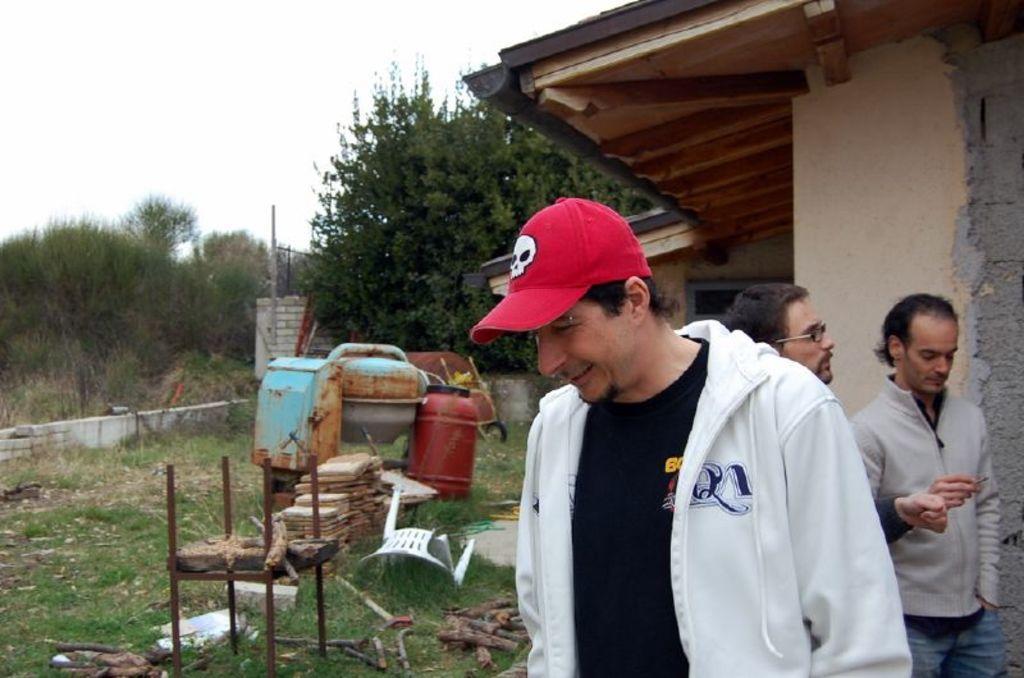How would you summarize this image in a sentence or two? In this image we can see many objects on the ground. There are few trees and plants in the image. There are few people at the right side of the image. A person is wearing a cap. There is a house in the image. We can see the sky in the image. 